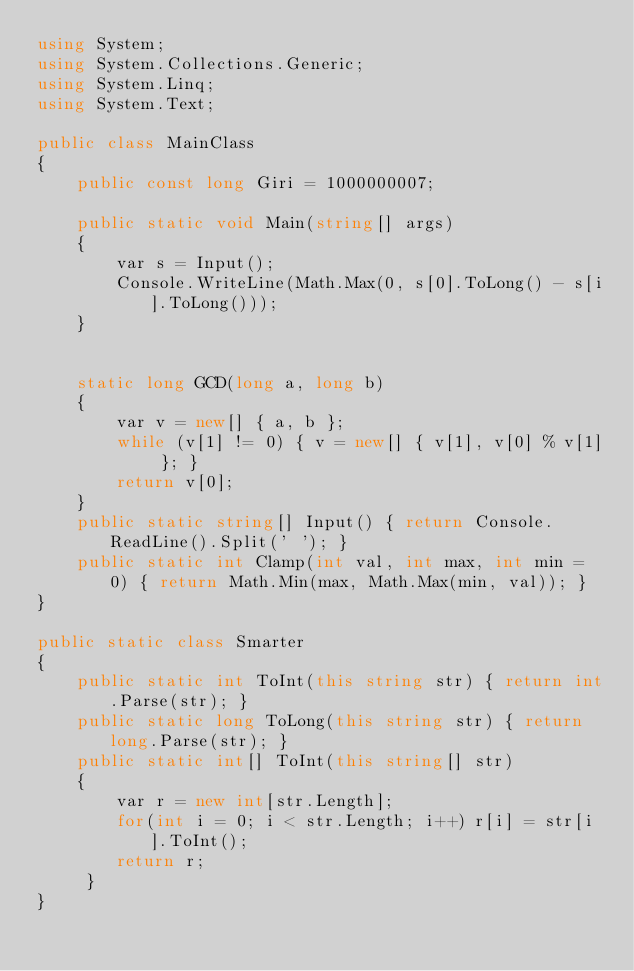Convert code to text. <code><loc_0><loc_0><loc_500><loc_500><_C#_>using System;
using System.Collections.Generic;
using System.Linq;
using System.Text;

public class MainClass
{
	public const long Giri = 1000000007;
	
	public static void Main(string[] args)
	{
		var s = Input();
		Console.WriteLine(Math.Max(0, s[0].ToLong() - s[i].ToLong()));
	}


	static long GCD(long a, long b)
	{
		var v = new[] { a, b };
		while (v[1] != 0) { v = new[] { v[1], v[0] % v[1] }; }
		return v[0];
	}
	public static string[] Input() { return Console.ReadLine().Split(' '); }
	public static int Clamp(int val, int max, int min = 0) { return Math.Min(max, Math.Max(min, val)); }
}

public static class Smarter
{
	public static int ToInt(this string str) { return int.Parse(str); }
	public static long ToLong(this string str) { return long.Parse(str); }
	public static int[] ToInt(this string[] str)
	{
		var r = new int[str.Length];
		for(int i = 0; i < str.Length; i++) r[i] = str[i].ToInt();
		return r;
	 }
}
</code> 